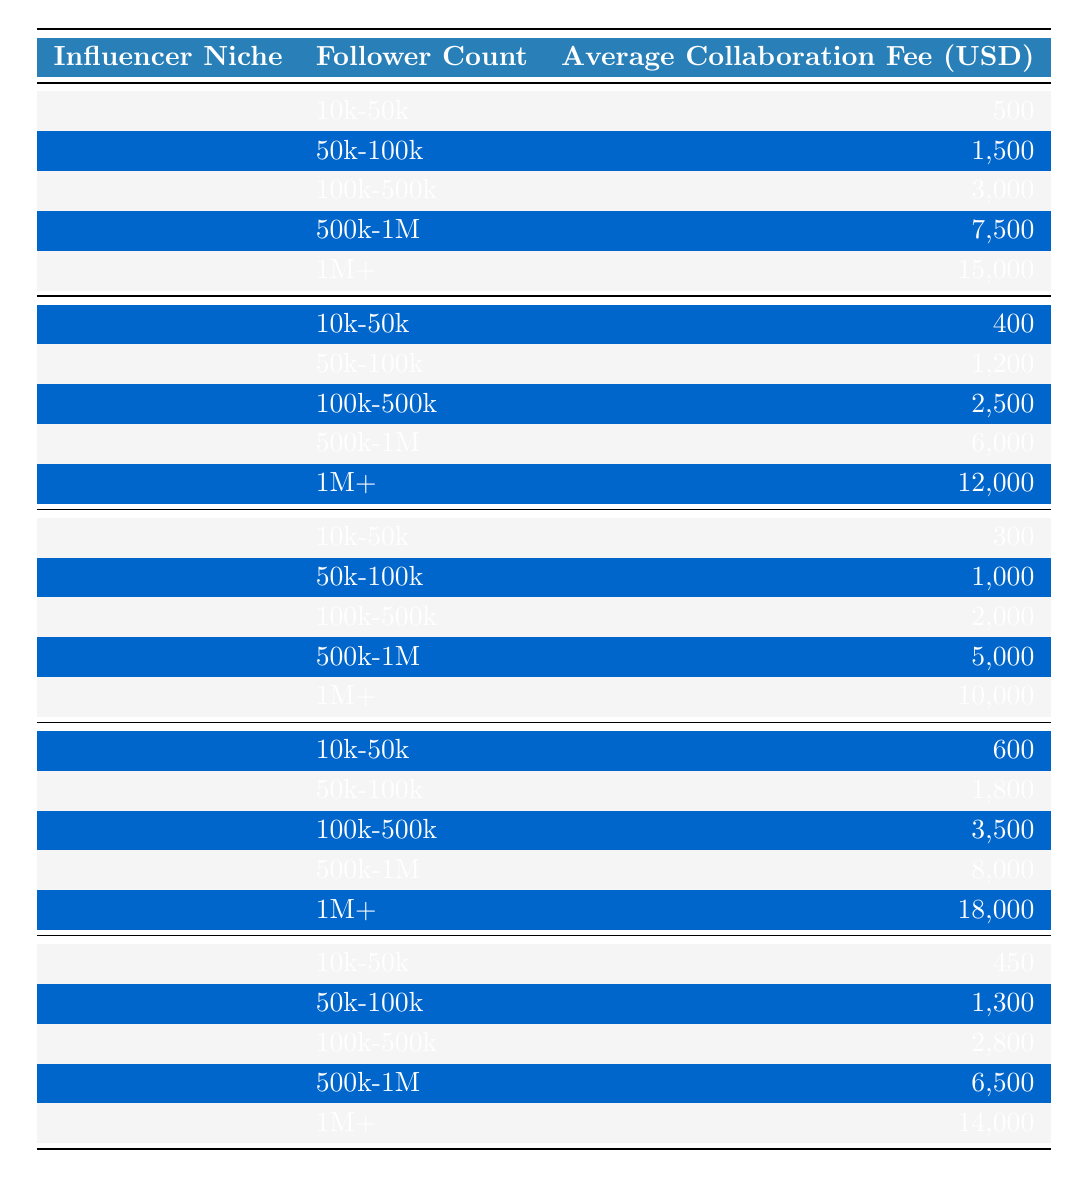What is the average collaboration fee for influencers in the Fashion niche with 100k-500k followers? According to the table, the average collaboration fee for the Fashion niche with 100k-500k followers is listed as 3,000 USD.
Answer: 3,000 USD Which influencer niche commands the highest average collaboration fee for the follower range of 1M+? In the table, the average collaboration fee for the Travel niche with 1M+ followers is 18,000 USD, which is the highest compared to other niches.
Answer: Travel niche How much more does a Fashion influencer with 1M+ followers earn compared to a Fitness influencer with the same follower count? For the Fashion niche with 1M+ followers, the fee is 15,000 USD, and for Fitness, it's 10,000 USD. The difference is 15,000 - 10,000 = 5,000 USD.
Answer: 5,000 USD Is the average collaboration fee for a Beauty influencer with 50k-100k followers greater than that of a Tech influencer with the same follower count? The average collaboration fee for Beauty influencers (1,200 USD) is greater than that for Tech influencers (1,300 USD), making the statement false.
Answer: No What is the average collaboration fee for an influencer in the Fitness niche across all follower counts? To find the average, sum the fees for Fitness: 300 + 1,000 + 2,000 + 5,000 + 10,000 = 18,300. Divide by 5 (the number of data points) gives 18,300 / 5 = 3,660 USD.
Answer: 3,660 USD In which niche does the follower count range of 500k-1M have the lowest average collaboration fee? The table shows that in the Fitness niche, the 500k-1M follower count has an average fee of 5,000 USD, which is lower than that in other niches for the same follower range.
Answer: Fitness niche What is the total collaboration fee for a Travel influencer with 100k-500k followers and a Beauty influencer with 500k-1M followers? The Travel average fee for 100k-500k followers is 3,500 USD, and for Beauty, it's 6,000 USD. Adding both fees gives 3,500 + 6,000 = 9,500 USD.
Answer: 9,500 USD Are there any niches that have the same average collaboration fee for 10k-50k followers? Yes, the Fitness niche has an average fee of 300 USD, and the Beauty niche has 400 USD; they are different, thus no niches have the same fee for that count.
Answer: No What is the difference in average collaboration fees between Tech and Fashion influencers with 50k-100k followers? The average fee for Tech influencers is 1,300 USD and for Fashion influencers it's 1,500 USD. Therefore, the difference is 1,500 - 1,300 = 200 USD.
Answer: 200 USD Which follower count for the Travel niche has the highest collaboration fee? The highest average collaboration fee in the Travel niche is 18,000 USD for the follower range of 1M+.
Answer: 1M+ followers 